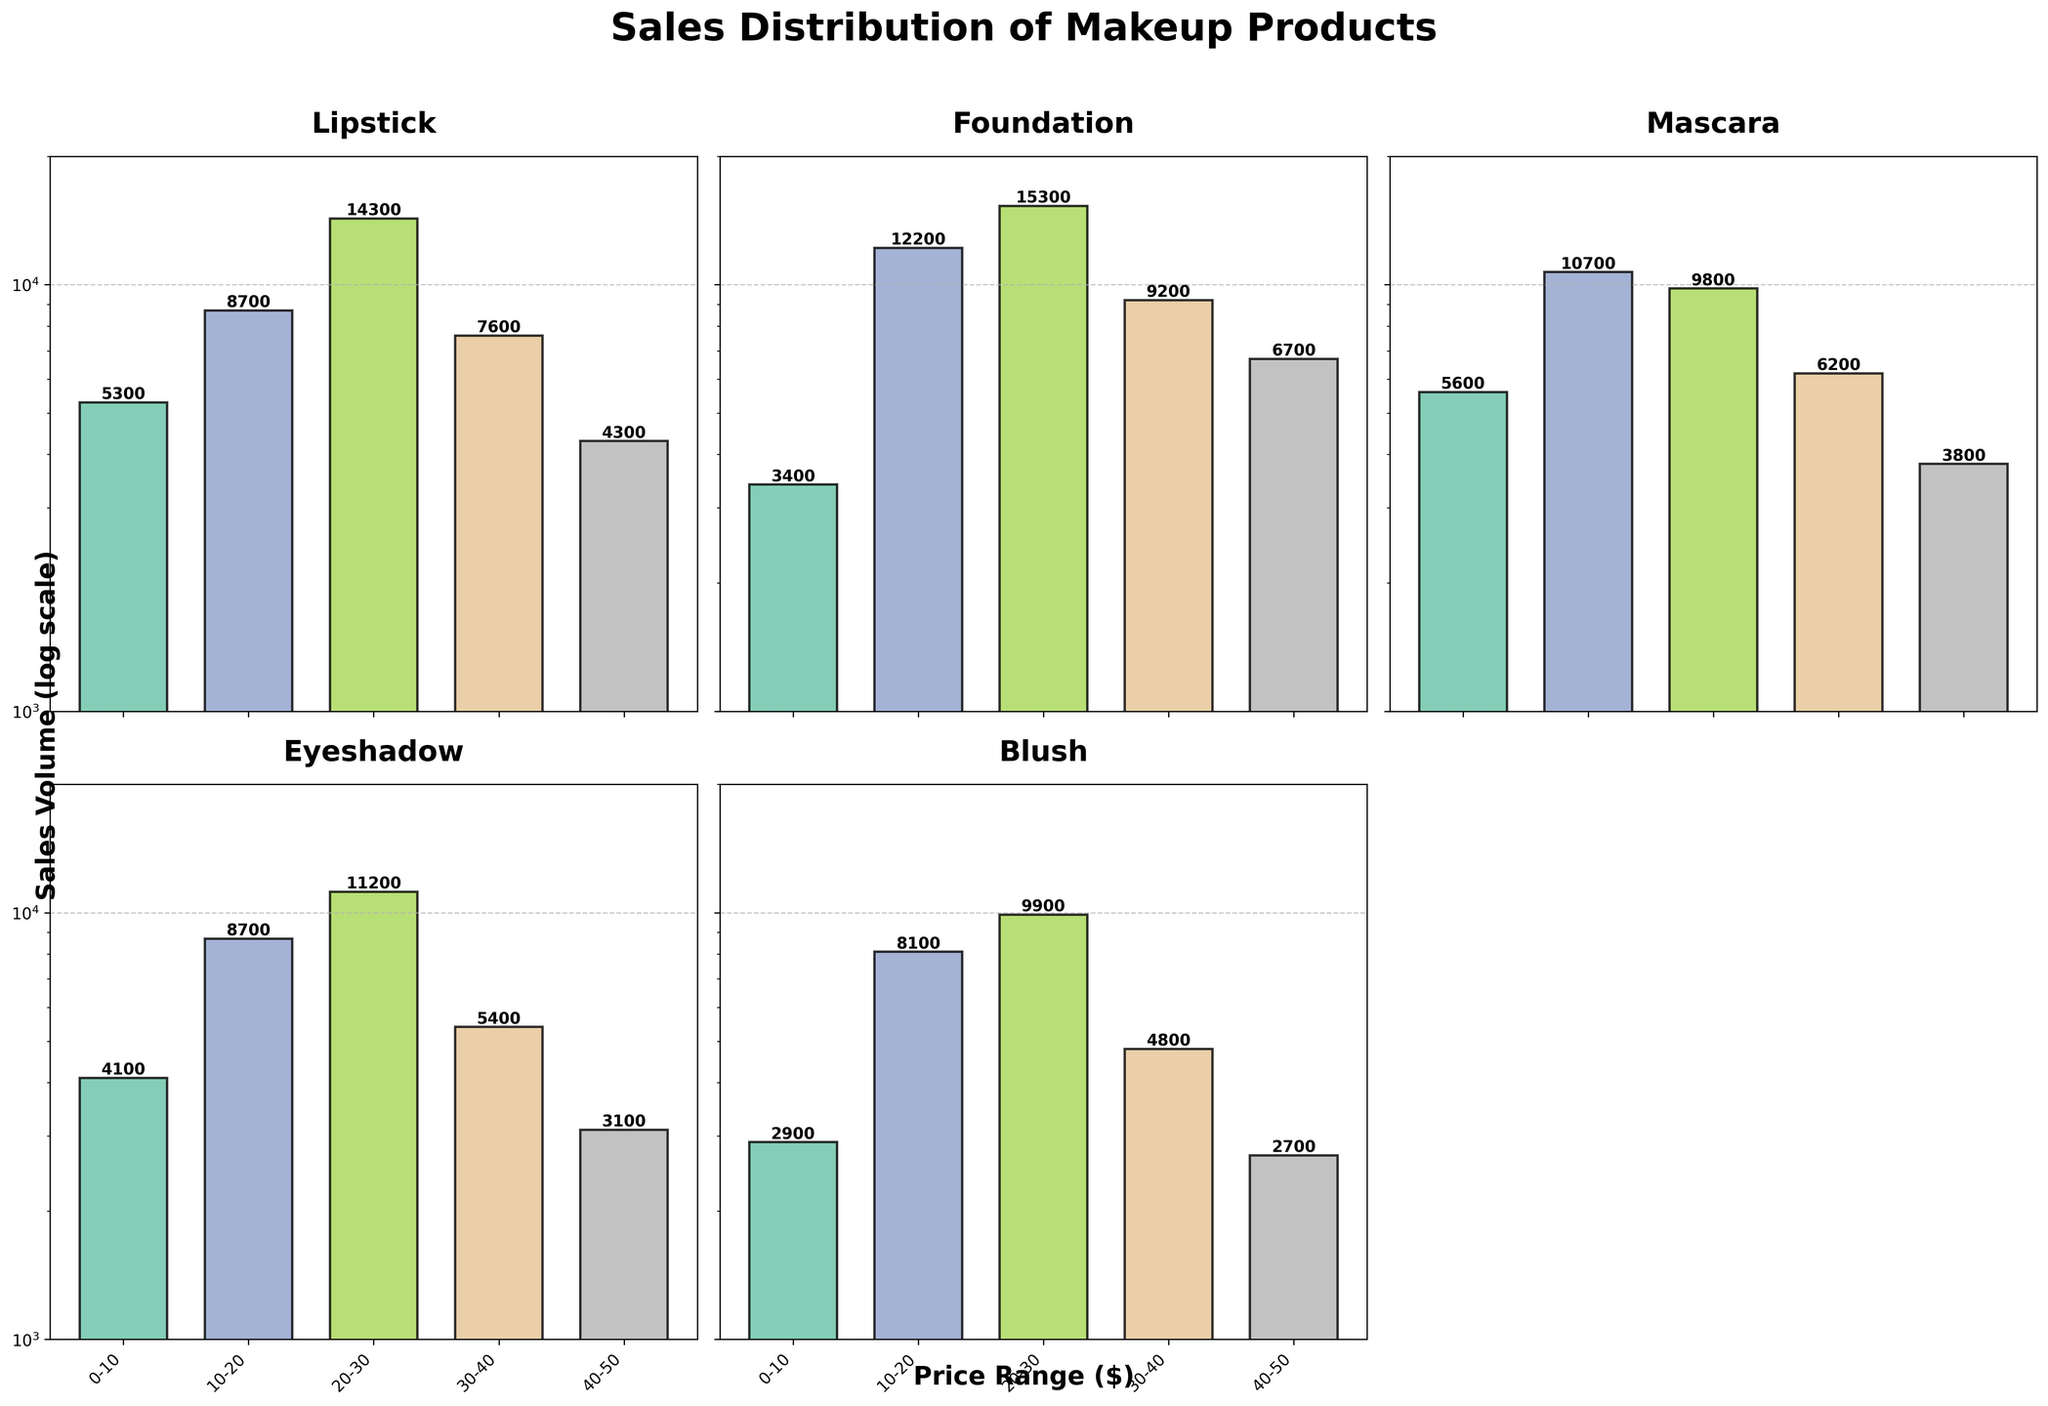Which product category has the highest sales volume in the 20-30 price range? To find the answer, look at the bar heights in the subplot corresponding to each product category for the 20-30 price range. The bar for Foundation is higher than the others in this category.
Answer: Foundation What is the price range for which Lipstick has its highest sales volume? In the Lipstick subplot, identify the bar with the highest height. The highest bar is in the 20-30 price range.
Answer: 20-30 Which two product categories have the lowest sales volume in the 40-50 price range? For each relevant subplot, find the 40-50 range bar and compare their heights. Blush and Eyeshadow have the smallest bars in this price range.
Answer: Blush and Eyeshadow Compare the sales volume of Mascara in the price ranges 0-10 and 10-20. What is the difference? Locate the bars for Mascara in the 0-10 and 10-20 price ranges. The 0-10 range has a height of 5600, and the 10-20 range has 10700. Subtract 5600 from 10700 to get 5100.
Answer: 5100 What is the common y-axis scale used across all subplots? All subplots share the same y-axis. Identify the y-axis settings, noting that it is a log scale with a range from 1000 to 20000.
Answer: Log scale from 1000 to 20000 Which product category has the closest sales volumes in the price ranges 20-30 and 30-40? Compare the bars for 20-30 and 30-40 within each subplot to see which pair of bars are closest in height. The Foundation category shows similar heights for these ranges.
Answer: Foundation What is the total sales volume for Blush across all price ranges? Sum the heights of bars in the Blush subplot: 2900 (0-10) + 8100 (10-20) + 9900 (20-30) + 4800 (30-40) + 2700 (40-50) = 28400.
Answer: 28400 Which product category shows the steepest decline in sales volume as the price range increases? Examine all subplots from left to right and identify which category has bars that decrease the fastest. The Blush category's bars decrease steeply as the price ranges increase.
Answer: Blush 